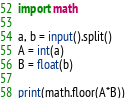Convert code to text. <code><loc_0><loc_0><loc_500><loc_500><_Python_>import math

a, b = input().split()
A = int(a)
B = float(b)

print(math.floor(A*B))</code> 